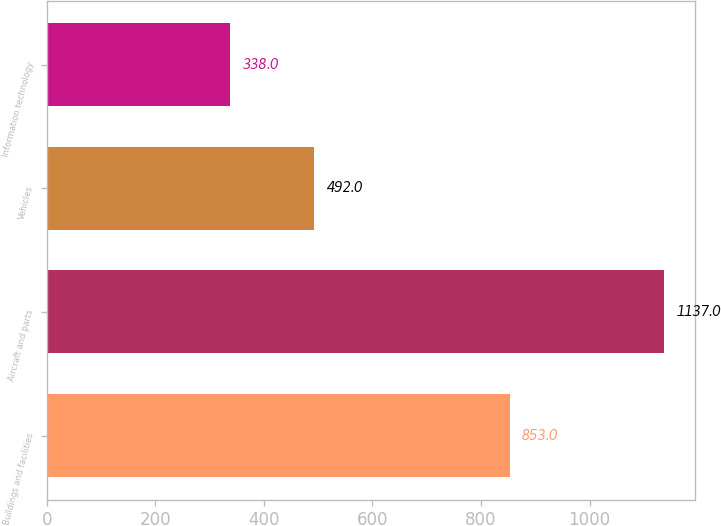Convert chart. <chart><loc_0><loc_0><loc_500><loc_500><bar_chart><fcel>Buildings and facilities<fcel>Aircraft and parts<fcel>Vehicles<fcel>Information technology<nl><fcel>853<fcel>1137<fcel>492<fcel>338<nl></chart> 